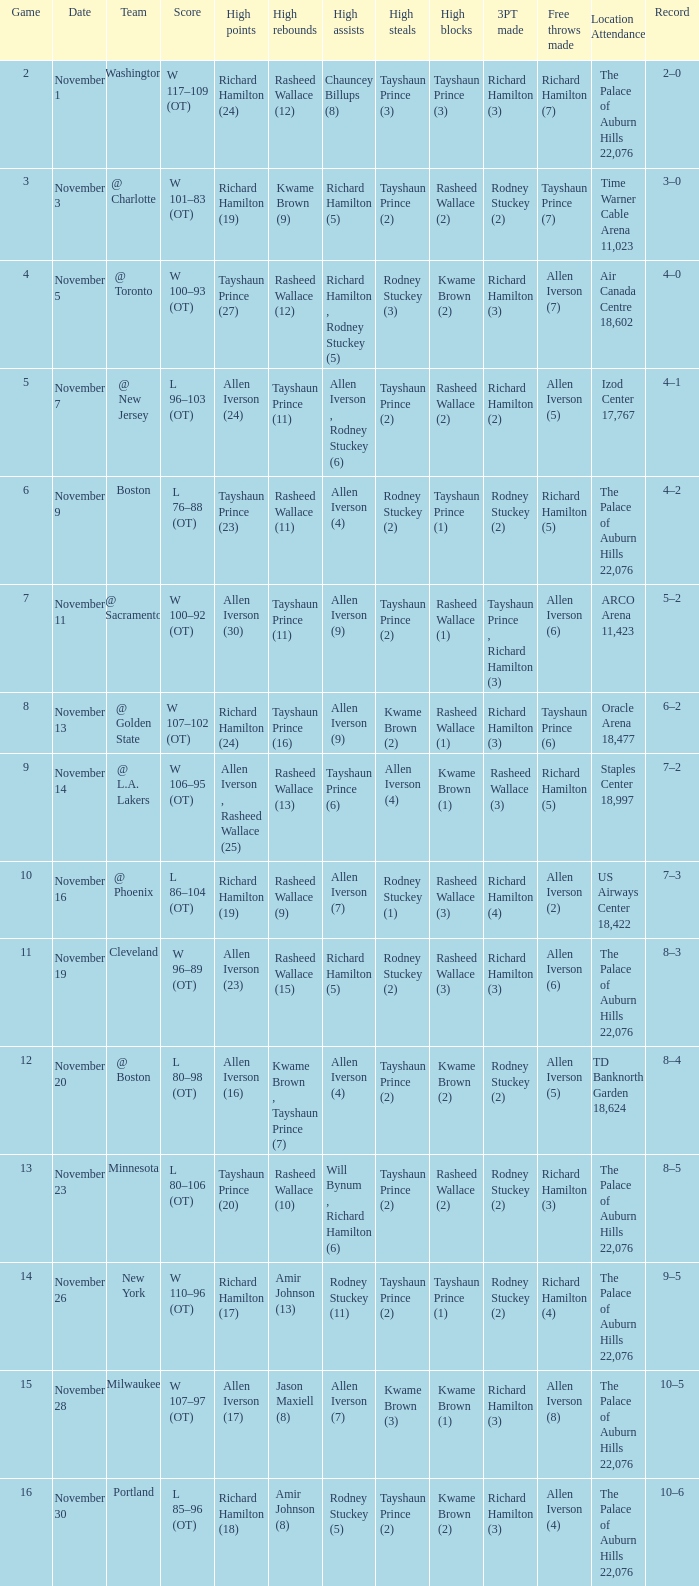What is High Points, when Game is less than 10, and when High Assists is "Chauncey Billups (8)"? Richard Hamilton (24). Can you give me this table as a dict? {'header': ['Game', 'Date', 'Team', 'Score', 'High points', 'High rebounds', 'High assists', 'High steals', 'High blocks', '3PT made', 'Free throws made', 'Location Attendance', 'Record'], 'rows': [['2', 'November 1', 'Washington', 'W 117–109 (OT)', 'Richard Hamilton (24)', 'Rasheed Wallace (12)', 'Chauncey Billups (8)', 'Tayshaun Prince (3)', 'Tayshaun Prince (3)', 'Richard Hamilton (3)', 'Richard Hamilton (7)', 'The Palace of Auburn Hills 22,076', '2–0'], ['3', 'November 3', '@ Charlotte', 'W 101–83 (OT)', 'Richard Hamilton (19)', 'Kwame Brown (9)', 'Richard Hamilton (5)', 'Tayshaun Prince (2)', 'Rasheed Wallace (2)', 'Rodney Stuckey (2)', 'Tayshaun Prince (7)', 'Time Warner Cable Arena 11,023', '3–0'], ['4', 'November 5', '@ Toronto', 'W 100–93 (OT)', 'Tayshaun Prince (27)', 'Rasheed Wallace (12)', 'Richard Hamilton , Rodney Stuckey (5)', 'Rodney Stuckey (3)', 'Kwame Brown (2)', 'Richard Hamilton (3)', 'Allen Iverson (7)', 'Air Canada Centre 18,602', '4–0'], ['5', 'November 7', '@ New Jersey', 'L 96–103 (OT)', 'Allen Iverson (24)', 'Tayshaun Prince (11)', 'Allen Iverson , Rodney Stuckey (6)', 'Tayshaun Prince (2)', 'Rasheed Wallace (2)', 'Richard Hamilton (2)', 'Allen Iverson (5)', 'Izod Center 17,767', '4–1'], ['6', 'November 9', 'Boston', 'L 76–88 (OT)', 'Tayshaun Prince (23)', 'Rasheed Wallace (11)', 'Allen Iverson (4)', 'Rodney Stuckey (2)', 'Tayshaun Prince (1)', 'Rodney Stuckey (2)', 'Richard Hamilton (5)', 'The Palace of Auburn Hills 22,076', '4–2'], ['7', 'November 11', '@ Sacramento', 'W 100–92 (OT)', 'Allen Iverson (30)', 'Tayshaun Prince (11)', 'Allen Iverson (9)', 'Tayshaun Prince (2)', 'Rasheed Wallace (1)', 'Tayshaun Prince , Richard Hamilton (3)', 'Allen Iverson (6)', 'ARCO Arena 11,423', '5–2'], ['8', 'November 13', '@ Golden State', 'W 107–102 (OT)', 'Richard Hamilton (24)', 'Tayshaun Prince (16)', 'Allen Iverson (9)', 'Kwame Brown (2)', 'Rasheed Wallace (1)', 'Richard Hamilton (3)', 'Tayshaun Prince (6)', 'Oracle Arena 18,477', '6–2'], ['9', 'November 14', '@ L.A. Lakers', 'W 106–95 (OT)', 'Allen Iverson , Rasheed Wallace (25)', 'Rasheed Wallace (13)', 'Tayshaun Prince (6)', 'Allen Iverson (4)', 'Kwame Brown (1)', 'Rasheed Wallace (3)', 'Richard Hamilton (5)', 'Staples Center 18,997', '7–2'], ['10', 'November 16', '@ Phoenix', 'L 86–104 (OT)', 'Richard Hamilton (19)', 'Rasheed Wallace (9)', 'Allen Iverson (7)', 'Rodney Stuckey (1)', 'Rasheed Wallace (3)', 'Richard Hamilton (4)', 'Allen Iverson (2)', 'US Airways Center 18,422', '7–3'], ['11', 'November 19', 'Cleveland', 'W 96–89 (OT)', 'Allen Iverson (23)', 'Rasheed Wallace (15)', 'Richard Hamilton (5)', 'Rodney Stuckey (2)', 'Rasheed Wallace (3)', 'Richard Hamilton (3)', 'Allen Iverson (6)', 'The Palace of Auburn Hills 22,076', '8–3'], ['12', 'November 20', '@ Boston', 'L 80–98 (OT)', 'Allen Iverson (16)', 'Kwame Brown , Tayshaun Prince (7)', 'Allen Iverson (4)', 'Tayshaun Prince (2)', 'Kwame Brown (2)', 'Rodney Stuckey (2)', 'Allen Iverson (5)', 'TD Banknorth Garden 18,624', '8–4'], ['13', 'November 23', 'Minnesota', 'L 80–106 (OT)', 'Tayshaun Prince (20)', 'Rasheed Wallace (10)', 'Will Bynum , Richard Hamilton (6)', 'Tayshaun Prince (2)', 'Rasheed Wallace (2)', 'Rodney Stuckey (2)', 'Richard Hamilton (3)', 'The Palace of Auburn Hills 22,076', '8–5'], ['14', 'November 26', 'New York', 'W 110–96 (OT)', 'Richard Hamilton (17)', 'Amir Johnson (13)', 'Rodney Stuckey (11)', 'Tayshaun Prince (2)', 'Tayshaun Prince (1)', 'Rodney Stuckey (2)', 'Richard Hamilton (4)', 'The Palace of Auburn Hills 22,076', '9–5'], ['15', 'November 28', 'Milwaukee', 'W 107–97 (OT)', 'Allen Iverson (17)', 'Jason Maxiell (8)', 'Allen Iverson (7)', 'Kwame Brown (3)', 'Kwame Brown (1)', 'Richard Hamilton (3)', 'Allen Iverson (8)', 'The Palace of Auburn Hills 22,076', '10–5'], ['16', 'November 30', 'Portland', 'L 85–96 (OT)', 'Richard Hamilton (18)', 'Amir Johnson (8)', 'Rodney Stuckey (5)', 'Tayshaun Prince (2)', 'Kwame Brown (2)', 'Richard Hamilton (3)', 'Allen Iverson (4)', 'The Palace of Auburn Hills 22,076', '10–6']]} 